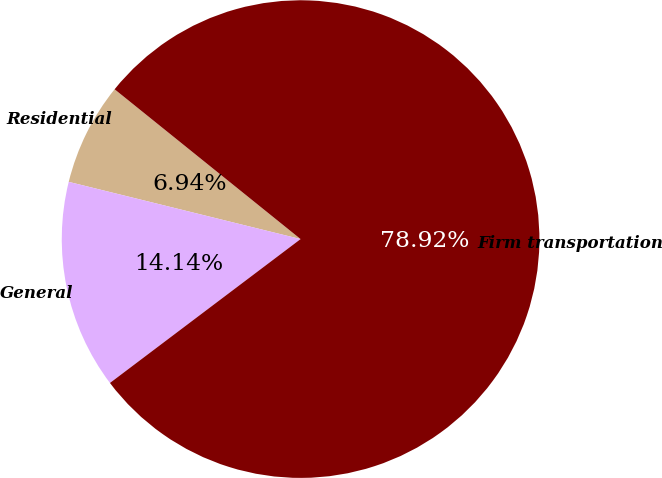<chart> <loc_0><loc_0><loc_500><loc_500><pie_chart><fcel>Residential<fcel>General<fcel>Firm transportation<nl><fcel>6.94%<fcel>14.14%<fcel>78.91%<nl></chart> 